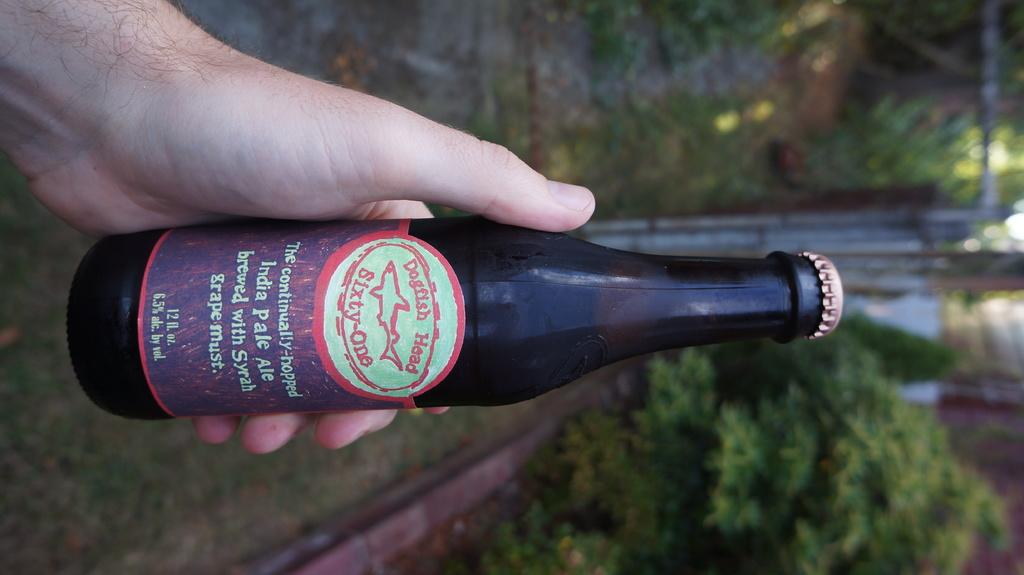<image>
Give a short and clear explanation of the subsequent image. a bottle being held outside labeled as dogfish head sixty-one 